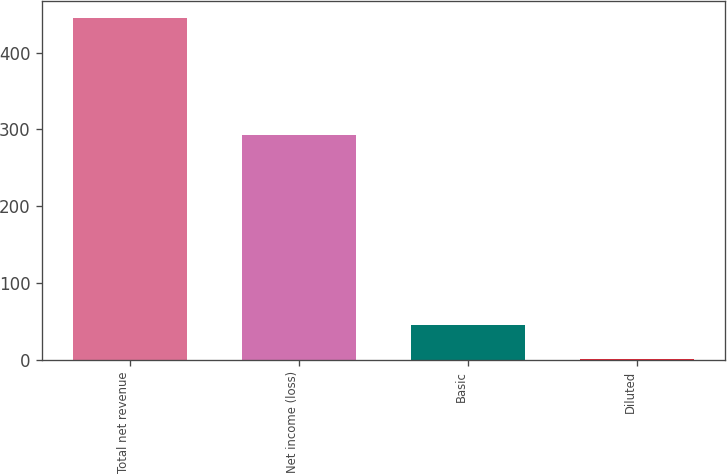Convert chart. <chart><loc_0><loc_0><loc_500><loc_500><bar_chart><fcel>Total net revenue<fcel>Net income (loss)<fcel>Basic<fcel>Diluted<nl><fcel>445<fcel>292<fcel>45.39<fcel>0.99<nl></chart> 